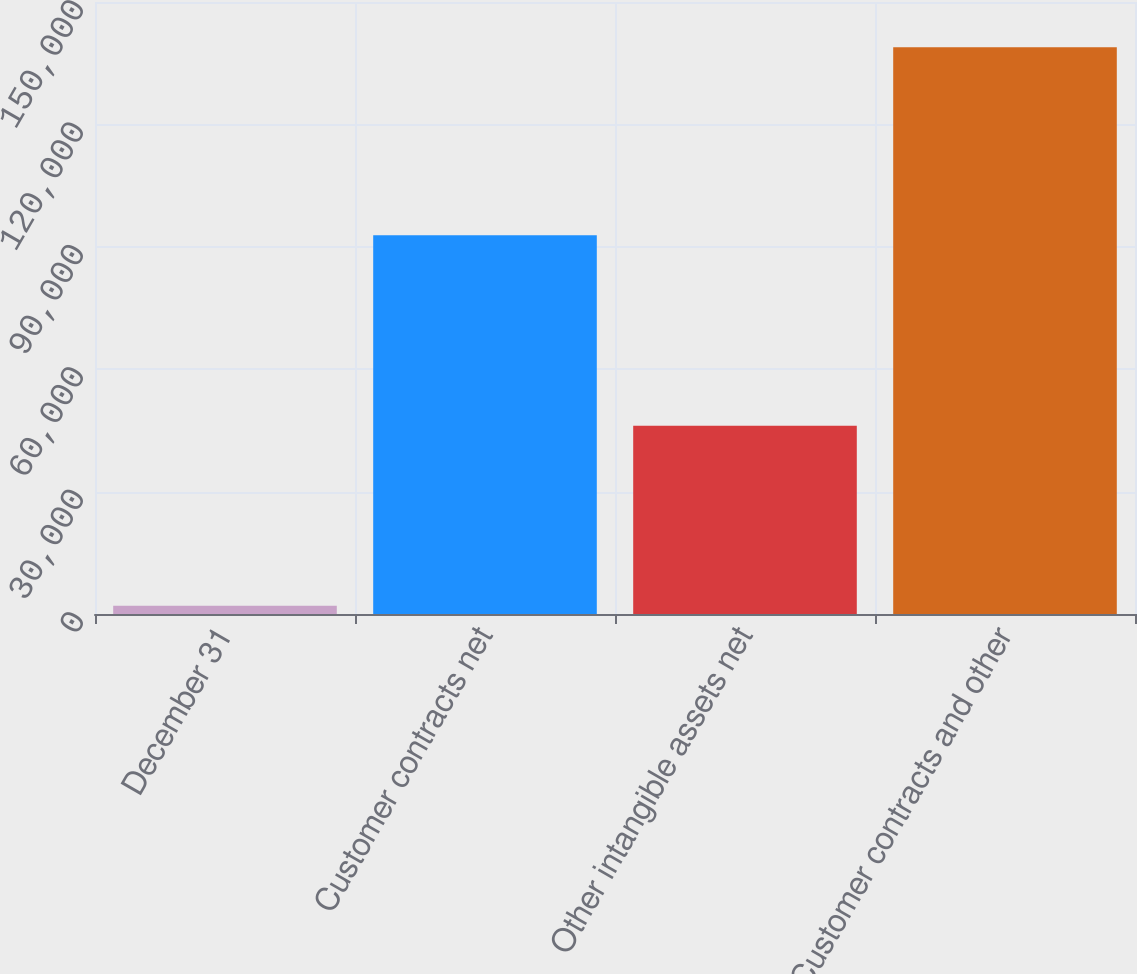Convert chart. <chart><loc_0><loc_0><loc_500><loc_500><bar_chart><fcel>December 31<fcel>Customer contracts net<fcel>Other intangible assets net<fcel>Customer contracts and other<nl><fcel>2015<fcel>92815<fcel>46116<fcel>138931<nl></chart> 